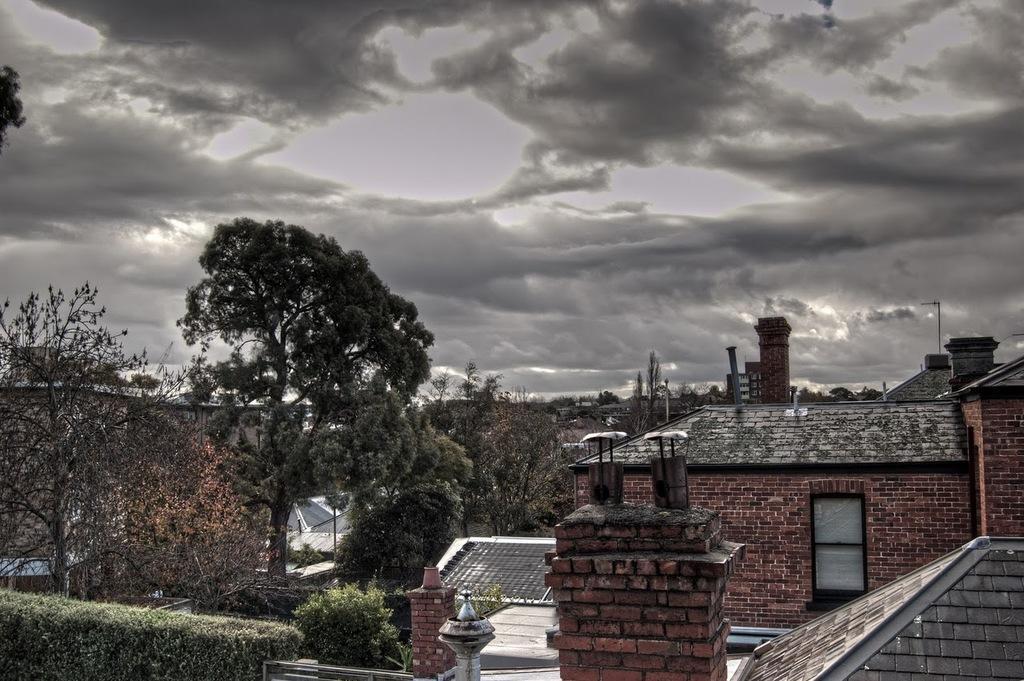Describe this image in one or two sentences. In this image we can see a few buildings, there are some trees, poles, plants and a door, in the background we can see the sky with clouds. 